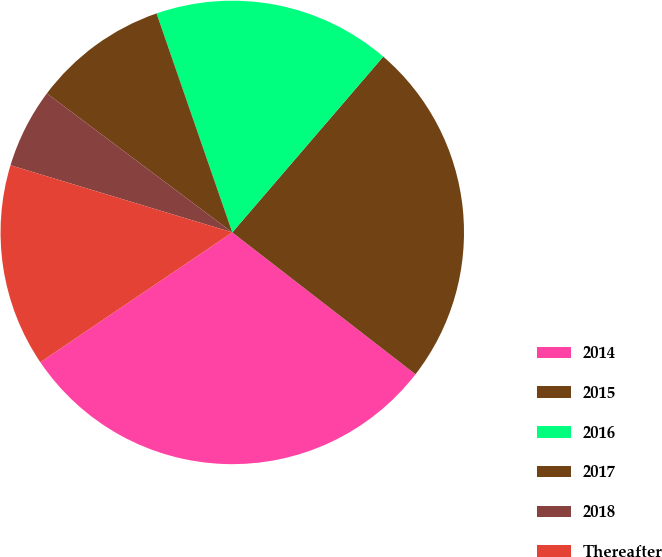<chart> <loc_0><loc_0><loc_500><loc_500><pie_chart><fcel>2014<fcel>2015<fcel>2016<fcel>2017<fcel>2018<fcel>Thereafter<nl><fcel>30.05%<fcel>24.19%<fcel>16.59%<fcel>9.46%<fcel>5.56%<fcel>14.14%<nl></chart> 